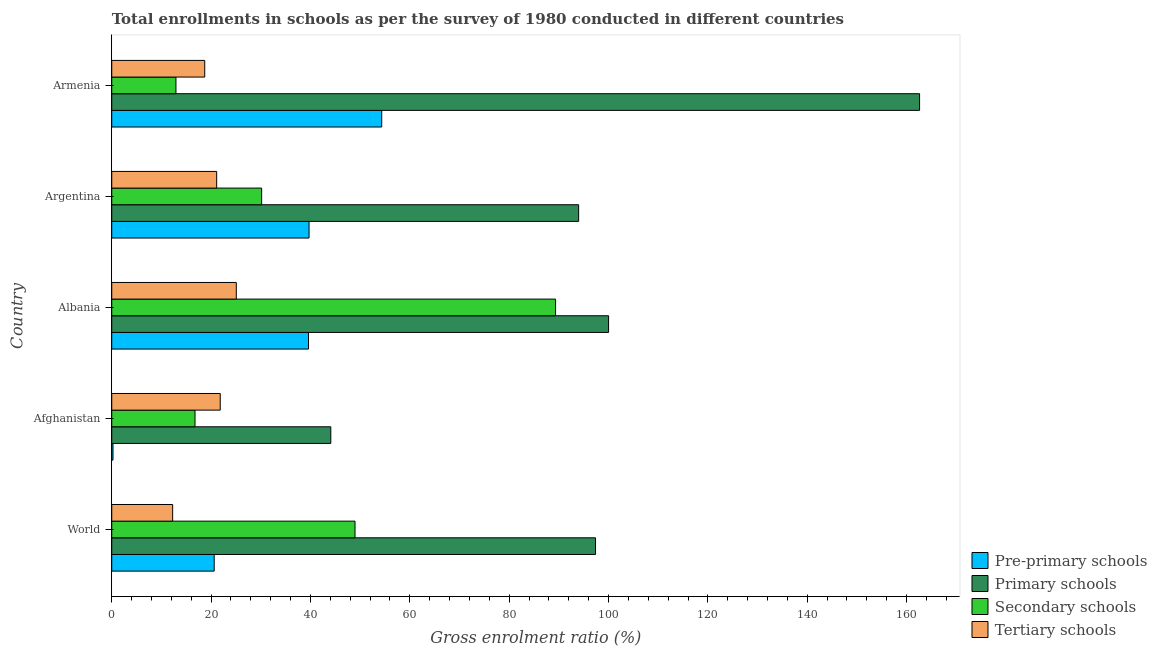How many different coloured bars are there?
Offer a terse response. 4. How many groups of bars are there?
Provide a succinct answer. 5. Are the number of bars per tick equal to the number of legend labels?
Make the answer very short. Yes. Are the number of bars on each tick of the Y-axis equal?
Give a very brief answer. Yes. What is the label of the 1st group of bars from the top?
Your response must be concise. Armenia. What is the gross enrolment ratio in pre-primary schools in World?
Ensure brevity in your answer.  20.62. Across all countries, what is the maximum gross enrolment ratio in tertiary schools?
Your response must be concise. 25.07. Across all countries, what is the minimum gross enrolment ratio in pre-primary schools?
Keep it short and to the point. 0.25. In which country was the gross enrolment ratio in secondary schools maximum?
Make the answer very short. Albania. In which country was the gross enrolment ratio in pre-primary schools minimum?
Offer a terse response. Afghanistan. What is the total gross enrolment ratio in secondary schools in the graph?
Keep it short and to the point. 198.17. What is the difference between the gross enrolment ratio in primary schools in Argentina and that in Armenia?
Your answer should be compact. -68.63. What is the difference between the gross enrolment ratio in primary schools in Argentina and the gross enrolment ratio in secondary schools in Albania?
Your answer should be very brief. 4.64. What is the average gross enrolment ratio in secondary schools per country?
Offer a terse response. 39.63. What is the difference between the gross enrolment ratio in pre-primary schools and gross enrolment ratio in primary schools in Argentina?
Keep it short and to the point. -54.27. In how many countries, is the gross enrolment ratio in pre-primary schools greater than 36 %?
Ensure brevity in your answer.  3. What is the ratio of the gross enrolment ratio in tertiary schools in Albania to that in Argentina?
Keep it short and to the point. 1.19. Is the gross enrolment ratio in pre-primary schools in Albania less than that in World?
Your response must be concise. No. What is the difference between the highest and the second highest gross enrolment ratio in secondary schools?
Provide a short and direct response. 40.37. What is the difference between the highest and the lowest gross enrolment ratio in secondary schools?
Your answer should be compact. 76.42. In how many countries, is the gross enrolment ratio in pre-primary schools greater than the average gross enrolment ratio in pre-primary schools taken over all countries?
Your answer should be very brief. 3. What does the 3rd bar from the top in Albania represents?
Give a very brief answer. Primary schools. What does the 4th bar from the bottom in Albania represents?
Provide a short and direct response. Tertiary schools. How many countries are there in the graph?
Offer a very short reply. 5. What is the difference between two consecutive major ticks on the X-axis?
Keep it short and to the point. 20. Does the graph contain any zero values?
Offer a terse response. No. Where does the legend appear in the graph?
Keep it short and to the point. Bottom right. How many legend labels are there?
Your answer should be compact. 4. How are the legend labels stacked?
Make the answer very short. Vertical. What is the title of the graph?
Provide a short and direct response. Total enrollments in schools as per the survey of 1980 conducted in different countries. What is the label or title of the Y-axis?
Give a very brief answer. Country. What is the Gross enrolment ratio (%) in Pre-primary schools in World?
Offer a very short reply. 20.62. What is the Gross enrolment ratio (%) in Primary schools in World?
Your answer should be very brief. 97.38. What is the Gross enrolment ratio (%) of Secondary schools in World?
Give a very brief answer. 48.97. What is the Gross enrolment ratio (%) of Tertiary schools in World?
Offer a terse response. 12.26. What is the Gross enrolment ratio (%) of Pre-primary schools in Afghanistan?
Make the answer very short. 0.25. What is the Gross enrolment ratio (%) of Primary schools in Afghanistan?
Ensure brevity in your answer.  44.1. What is the Gross enrolment ratio (%) in Secondary schools in Afghanistan?
Offer a very short reply. 16.76. What is the Gross enrolment ratio (%) in Tertiary schools in Afghanistan?
Offer a very short reply. 21.84. What is the Gross enrolment ratio (%) of Pre-primary schools in Albania?
Offer a terse response. 39.61. What is the Gross enrolment ratio (%) of Primary schools in Albania?
Ensure brevity in your answer.  100.01. What is the Gross enrolment ratio (%) of Secondary schools in Albania?
Your answer should be very brief. 89.34. What is the Gross enrolment ratio (%) in Tertiary schools in Albania?
Ensure brevity in your answer.  25.07. What is the Gross enrolment ratio (%) in Pre-primary schools in Argentina?
Ensure brevity in your answer.  39.72. What is the Gross enrolment ratio (%) in Primary schools in Argentina?
Make the answer very short. 93.98. What is the Gross enrolment ratio (%) of Secondary schools in Argentina?
Ensure brevity in your answer.  30.17. What is the Gross enrolment ratio (%) in Tertiary schools in Argentina?
Offer a very short reply. 21.12. What is the Gross enrolment ratio (%) of Pre-primary schools in Armenia?
Keep it short and to the point. 54.34. What is the Gross enrolment ratio (%) of Primary schools in Armenia?
Keep it short and to the point. 162.62. What is the Gross enrolment ratio (%) of Secondary schools in Armenia?
Keep it short and to the point. 12.93. What is the Gross enrolment ratio (%) of Tertiary schools in Armenia?
Offer a terse response. 18.72. Across all countries, what is the maximum Gross enrolment ratio (%) of Pre-primary schools?
Give a very brief answer. 54.34. Across all countries, what is the maximum Gross enrolment ratio (%) of Primary schools?
Provide a succinct answer. 162.62. Across all countries, what is the maximum Gross enrolment ratio (%) of Secondary schools?
Ensure brevity in your answer.  89.34. Across all countries, what is the maximum Gross enrolment ratio (%) in Tertiary schools?
Your response must be concise. 25.07. Across all countries, what is the minimum Gross enrolment ratio (%) of Pre-primary schools?
Provide a short and direct response. 0.25. Across all countries, what is the minimum Gross enrolment ratio (%) in Primary schools?
Ensure brevity in your answer.  44.1. Across all countries, what is the minimum Gross enrolment ratio (%) of Secondary schools?
Keep it short and to the point. 12.93. Across all countries, what is the minimum Gross enrolment ratio (%) of Tertiary schools?
Provide a short and direct response. 12.26. What is the total Gross enrolment ratio (%) in Pre-primary schools in the graph?
Offer a very short reply. 154.54. What is the total Gross enrolment ratio (%) in Primary schools in the graph?
Provide a short and direct response. 498.09. What is the total Gross enrolment ratio (%) in Secondary schools in the graph?
Ensure brevity in your answer.  198.17. What is the total Gross enrolment ratio (%) in Tertiary schools in the graph?
Offer a very short reply. 99.01. What is the difference between the Gross enrolment ratio (%) in Pre-primary schools in World and that in Afghanistan?
Provide a succinct answer. 20.37. What is the difference between the Gross enrolment ratio (%) in Primary schools in World and that in Afghanistan?
Keep it short and to the point. 53.29. What is the difference between the Gross enrolment ratio (%) of Secondary schools in World and that in Afghanistan?
Your answer should be compact. 32.21. What is the difference between the Gross enrolment ratio (%) in Tertiary schools in World and that in Afghanistan?
Your response must be concise. -9.58. What is the difference between the Gross enrolment ratio (%) of Pre-primary schools in World and that in Albania?
Offer a terse response. -18.98. What is the difference between the Gross enrolment ratio (%) in Primary schools in World and that in Albania?
Provide a short and direct response. -2.63. What is the difference between the Gross enrolment ratio (%) of Secondary schools in World and that in Albania?
Offer a very short reply. -40.37. What is the difference between the Gross enrolment ratio (%) of Tertiary schools in World and that in Albania?
Offer a very short reply. -12.81. What is the difference between the Gross enrolment ratio (%) of Pre-primary schools in World and that in Argentina?
Ensure brevity in your answer.  -19.1. What is the difference between the Gross enrolment ratio (%) in Primary schools in World and that in Argentina?
Provide a short and direct response. 3.4. What is the difference between the Gross enrolment ratio (%) of Secondary schools in World and that in Argentina?
Offer a terse response. 18.8. What is the difference between the Gross enrolment ratio (%) in Tertiary schools in World and that in Argentina?
Ensure brevity in your answer.  -8.86. What is the difference between the Gross enrolment ratio (%) in Pre-primary schools in World and that in Armenia?
Keep it short and to the point. -33.72. What is the difference between the Gross enrolment ratio (%) of Primary schools in World and that in Armenia?
Keep it short and to the point. -65.23. What is the difference between the Gross enrolment ratio (%) in Secondary schools in World and that in Armenia?
Offer a very short reply. 36.05. What is the difference between the Gross enrolment ratio (%) in Tertiary schools in World and that in Armenia?
Your answer should be very brief. -6.46. What is the difference between the Gross enrolment ratio (%) of Pre-primary schools in Afghanistan and that in Albania?
Your answer should be very brief. -39.35. What is the difference between the Gross enrolment ratio (%) in Primary schools in Afghanistan and that in Albania?
Keep it short and to the point. -55.92. What is the difference between the Gross enrolment ratio (%) in Secondary schools in Afghanistan and that in Albania?
Keep it short and to the point. -72.58. What is the difference between the Gross enrolment ratio (%) in Tertiary schools in Afghanistan and that in Albania?
Offer a terse response. -3.23. What is the difference between the Gross enrolment ratio (%) of Pre-primary schools in Afghanistan and that in Argentina?
Ensure brevity in your answer.  -39.46. What is the difference between the Gross enrolment ratio (%) of Primary schools in Afghanistan and that in Argentina?
Your answer should be very brief. -49.89. What is the difference between the Gross enrolment ratio (%) of Secondary schools in Afghanistan and that in Argentina?
Offer a terse response. -13.41. What is the difference between the Gross enrolment ratio (%) in Tertiary schools in Afghanistan and that in Argentina?
Make the answer very short. 0.72. What is the difference between the Gross enrolment ratio (%) in Pre-primary schools in Afghanistan and that in Armenia?
Give a very brief answer. -54.09. What is the difference between the Gross enrolment ratio (%) in Primary schools in Afghanistan and that in Armenia?
Give a very brief answer. -118.52. What is the difference between the Gross enrolment ratio (%) in Secondary schools in Afghanistan and that in Armenia?
Your answer should be compact. 3.84. What is the difference between the Gross enrolment ratio (%) of Tertiary schools in Afghanistan and that in Armenia?
Give a very brief answer. 3.12. What is the difference between the Gross enrolment ratio (%) of Pre-primary schools in Albania and that in Argentina?
Provide a succinct answer. -0.11. What is the difference between the Gross enrolment ratio (%) of Primary schools in Albania and that in Argentina?
Your answer should be compact. 6.03. What is the difference between the Gross enrolment ratio (%) in Secondary schools in Albania and that in Argentina?
Give a very brief answer. 59.17. What is the difference between the Gross enrolment ratio (%) of Tertiary schools in Albania and that in Argentina?
Your answer should be compact. 3.95. What is the difference between the Gross enrolment ratio (%) in Pre-primary schools in Albania and that in Armenia?
Your response must be concise. -14.74. What is the difference between the Gross enrolment ratio (%) of Primary schools in Albania and that in Armenia?
Give a very brief answer. -62.61. What is the difference between the Gross enrolment ratio (%) in Secondary schools in Albania and that in Armenia?
Keep it short and to the point. 76.42. What is the difference between the Gross enrolment ratio (%) of Tertiary schools in Albania and that in Armenia?
Provide a short and direct response. 6.35. What is the difference between the Gross enrolment ratio (%) in Pre-primary schools in Argentina and that in Armenia?
Your answer should be compact. -14.63. What is the difference between the Gross enrolment ratio (%) of Primary schools in Argentina and that in Armenia?
Keep it short and to the point. -68.63. What is the difference between the Gross enrolment ratio (%) in Secondary schools in Argentina and that in Armenia?
Keep it short and to the point. 17.25. What is the difference between the Gross enrolment ratio (%) in Tertiary schools in Argentina and that in Armenia?
Ensure brevity in your answer.  2.4. What is the difference between the Gross enrolment ratio (%) in Pre-primary schools in World and the Gross enrolment ratio (%) in Primary schools in Afghanistan?
Your response must be concise. -23.47. What is the difference between the Gross enrolment ratio (%) of Pre-primary schools in World and the Gross enrolment ratio (%) of Secondary schools in Afghanistan?
Offer a terse response. 3.86. What is the difference between the Gross enrolment ratio (%) of Pre-primary schools in World and the Gross enrolment ratio (%) of Tertiary schools in Afghanistan?
Offer a terse response. -1.22. What is the difference between the Gross enrolment ratio (%) of Primary schools in World and the Gross enrolment ratio (%) of Secondary schools in Afghanistan?
Your response must be concise. 80.62. What is the difference between the Gross enrolment ratio (%) of Primary schools in World and the Gross enrolment ratio (%) of Tertiary schools in Afghanistan?
Offer a terse response. 75.55. What is the difference between the Gross enrolment ratio (%) of Secondary schools in World and the Gross enrolment ratio (%) of Tertiary schools in Afghanistan?
Make the answer very short. 27.13. What is the difference between the Gross enrolment ratio (%) of Pre-primary schools in World and the Gross enrolment ratio (%) of Primary schools in Albania?
Offer a very short reply. -79.39. What is the difference between the Gross enrolment ratio (%) in Pre-primary schools in World and the Gross enrolment ratio (%) in Secondary schools in Albania?
Give a very brief answer. -68.72. What is the difference between the Gross enrolment ratio (%) in Pre-primary schools in World and the Gross enrolment ratio (%) in Tertiary schools in Albania?
Your answer should be compact. -4.45. What is the difference between the Gross enrolment ratio (%) of Primary schools in World and the Gross enrolment ratio (%) of Secondary schools in Albania?
Provide a short and direct response. 8.04. What is the difference between the Gross enrolment ratio (%) of Primary schools in World and the Gross enrolment ratio (%) of Tertiary schools in Albania?
Your answer should be very brief. 72.31. What is the difference between the Gross enrolment ratio (%) in Secondary schools in World and the Gross enrolment ratio (%) in Tertiary schools in Albania?
Offer a very short reply. 23.9. What is the difference between the Gross enrolment ratio (%) of Pre-primary schools in World and the Gross enrolment ratio (%) of Primary schools in Argentina?
Offer a very short reply. -73.36. What is the difference between the Gross enrolment ratio (%) in Pre-primary schools in World and the Gross enrolment ratio (%) in Secondary schools in Argentina?
Ensure brevity in your answer.  -9.55. What is the difference between the Gross enrolment ratio (%) of Pre-primary schools in World and the Gross enrolment ratio (%) of Tertiary schools in Argentina?
Provide a succinct answer. -0.5. What is the difference between the Gross enrolment ratio (%) in Primary schools in World and the Gross enrolment ratio (%) in Secondary schools in Argentina?
Your answer should be very brief. 67.21. What is the difference between the Gross enrolment ratio (%) of Primary schools in World and the Gross enrolment ratio (%) of Tertiary schools in Argentina?
Ensure brevity in your answer.  76.26. What is the difference between the Gross enrolment ratio (%) in Secondary schools in World and the Gross enrolment ratio (%) in Tertiary schools in Argentina?
Your response must be concise. 27.85. What is the difference between the Gross enrolment ratio (%) of Pre-primary schools in World and the Gross enrolment ratio (%) of Primary schools in Armenia?
Your response must be concise. -142. What is the difference between the Gross enrolment ratio (%) in Pre-primary schools in World and the Gross enrolment ratio (%) in Secondary schools in Armenia?
Provide a succinct answer. 7.7. What is the difference between the Gross enrolment ratio (%) of Pre-primary schools in World and the Gross enrolment ratio (%) of Tertiary schools in Armenia?
Your answer should be compact. 1.9. What is the difference between the Gross enrolment ratio (%) of Primary schools in World and the Gross enrolment ratio (%) of Secondary schools in Armenia?
Your answer should be compact. 84.46. What is the difference between the Gross enrolment ratio (%) of Primary schools in World and the Gross enrolment ratio (%) of Tertiary schools in Armenia?
Your response must be concise. 78.66. What is the difference between the Gross enrolment ratio (%) of Secondary schools in World and the Gross enrolment ratio (%) of Tertiary schools in Armenia?
Your answer should be compact. 30.25. What is the difference between the Gross enrolment ratio (%) in Pre-primary schools in Afghanistan and the Gross enrolment ratio (%) in Primary schools in Albania?
Provide a short and direct response. -99.76. What is the difference between the Gross enrolment ratio (%) of Pre-primary schools in Afghanistan and the Gross enrolment ratio (%) of Secondary schools in Albania?
Your answer should be very brief. -89.09. What is the difference between the Gross enrolment ratio (%) in Pre-primary schools in Afghanistan and the Gross enrolment ratio (%) in Tertiary schools in Albania?
Keep it short and to the point. -24.82. What is the difference between the Gross enrolment ratio (%) in Primary schools in Afghanistan and the Gross enrolment ratio (%) in Secondary schools in Albania?
Offer a terse response. -45.25. What is the difference between the Gross enrolment ratio (%) in Primary schools in Afghanistan and the Gross enrolment ratio (%) in Tertiary schools in Albania?
Give a very brief answer. 19.02. What is the difference between the Gross enrolment ratio (%) in Secondary schools in Afghanistan and the Gross enrolment ratio (%) in Tertiary schools in Albania?
Offer a very short reply. -8.31. What is the difference between the Gross enrolment ratio (%) of Pre-primary schools in Afghanistan and the Gross enrolment ratio (%) of Primary schools in Argentina?
Provide a succinct answer. -93.73. What is the difference between the Gross enrolment ratio (%) in Pre-primary schools in Afghanistan and the Gross enrolment ratio (%) in Secondary schools in Argentina?
Provide a short and direct response. -29.92. What is the difference between the Gross enrolment ratio (%) in Pre-primary schools in Afghanistan and the Gross enrolment ratio (%) in Tertiary schools in Argentina?
Provide a short and direct response. -20.87. What is the difference between the Gross enrolment ratio (%) of Primary schools in Afghanistan and the Gross enrolment ratio (%) of Secondary schools in Argentina?
Give a very brief answer. 13.92. What is the difference between the Gross enrolment ratio (%) of Primary schools in Afghanistan and the Gross enrolment ratio (%) of Tertiary schools in Argentina?
Your answer should be very brief. 22.97. What is the difference between the Gross enrolment ratio (%) in Secondary schools in Afghanistan and the Gross enrolment ratio (%) in Tertiary schools in Argentina?
Provide a succinct answer. -4.36. What is the difference between the Gross enrolment ratio (%) in Pre-primary schools in Afghanistan and the Gross enrolment ratio (%) in Primary schools in Armenia?
Provide a succinct answer. -162.36. What is the difference between the Gross enrolment ratio (%) of Pre-primary schools in Afghanistan and the Gross enrolment ratio (%) of Secondary schools in Armenia?
Your answer should be very brief. -12.67. What is the difference between the Gross enrolment ratio (%) in Pre-primary schools in Afghanistan and the Gross enrolment ratio (%) in Tertiary schools in Armenia?
Provide a succinct answer. -18.47. What is the difference between the Gross enrolment ratio (%) of Primary schools in Afghanistan and the Gross enrolment ratio (%) of Secondary schools in Armenia?
Make the answer very short. 31.17. What is the difference between the Gross enrolment ratio (%) of Primary schools in Afghanistan and the Gross enrolment ratio (%) of Tertiary schools in Armenia?
Provide a succinct answer. 25.38. What is the difference between the Gross enrolment ratio (%) in Secondary schools in Afghanistan and the Gross enrolment ratio (%) in Tertiary schools in Armenia?
Your response must be concise. -1.96. What is the difference between the Gross enrolment ratio (%) in Pre-primary schools in Albania and the Gross enrolment ratio (%) in Primary schools in Argentina?
Your answer should be compact. -54.38. What is the difference between the Gross enrolment ratio (%) in Pre-primary schools in Albania and the Gross enrolment ratio (%) in Secondary schools in Argentina?
Your answer should be compact. 9.43. What is the difference between the Gross enrolment ratio (%) of Pre-primary schools in Albania and the Gross enrolment ratio (%) of Tertiary schools in Argentina?
Offer a very short reply. 18.48. What is the difference between the Gross enrolment ratio (%) in Primary schools in Albania and the Gross enrolment ratio (%) in Secondary schools in Argentina?
Provide a succinct answer. 69.84. What is the difference between the Gross enrolment ratio (%) of Primary schools in Albania and the Gross enrolment ratio (%) of Tertiary schools in Argentina?
Your answer should be very brief. 78.89. What is the difference between the Gross enrolment ratio (%) in Secondary schools in Albania and the Gross enrolment ratio (%) in Tertiary schools in Argentina?
Offer a terse response. 68.22. What is the difference between the Gross enrolment ratio (%) in Pre-primary schools in Albania and the Gross enrolment ratio (%) in Primary schools in Armenia?
Make the answer very short. -123.01. What is the difference between the Gross enrolment ratio (%) of Pre-primary schools in Albania and the Gross enrolment ratio (%) of Secondary schools in Armenia?
Your answer should be very brief. 26.68. What is the difference between the Gross enrolment ratio (%) in Pre-primary schools in Albania and the Gross enrolment ratio (%) in Tertiary schools in Armenia?
Offer a terse response. 20.89. What is the difference between the Gross enrolment ratio (%) of Primary schools in Albania and the Gross enrolment ratio (%) of Secondary schools in Armenia?
Give a very brief answer. 87.09. What is the difference between the Gross enrolment ratio (%) in Primary schools in Albania and the Gross enrolment ratio (%) in Tertiary schools in Armenia?
Provide a short and direct response. 81.29. What is the difference between the Gross enrolment ratio (%) in Secondary schools in Albania and the Gross enrolment ratio (%) in Tertiary schools in Armenia?
Provide a succinct answer. 70.62. What is the difference between the Gross enrolment ratio (%) of Pre-primary schools in Argentina and the Gross enrolment ratio (%) of Primary schools in Armenia?
Provide a succinct answer. -122.9. What is the difference between the Gross enrolment ratio (%) in Pre-primary schools in Argentina and the Gross enrolment ratio (%) in Secondary schools in Armenia?
Make the answer very short. 26.79. What is the difference between the Gross enrolment ratio (%) in Pre-primary schools in Argentina and the Gross enrolment ratio (%) in Tertiary schools in Armenia?
Ensure brevity in your answer.  21. What is the difference between the Gross enrolment ratio (%) in Primary schools in Argentina and the Gross enrolment ratio (%) in Secondary schools in Armenia?
Your answer should be compact. 81.06. What is the difference between the Gross enrolment ratio (%) of Primary schools in Argentina and the Gross enrolment ratio (%) of Tertiary schools in Armenia?
Your answer should be very brief. 75.27. What is the difference between the Gross enrolment ratio (%) of Secondary schools in Argentina and the Gross enrolment ratio (%) of Tertiary schools in Armenia?
Your answer should be compact. 11.45. What is the average Gross enrolment ratio (%) in Pre-primary schools per country?
Provide a short and direct response. 30.91. What is the average Gross enrolment ratio (%) of Primary schools per country?
Make the answer very short. 99.62. What is the average Gross enrolment ratio (%) in Secondary schools per country?
Ensure brevity in your answer.  39.63. What is the average Gross enrolment ratio (%) of Tertiary schools per country?
Make the answer very short. 19.8. What is the difference between the Gross enrolment ratio (%) in Pre-primary schools and Gross enrolment ratio (%) in Primary schools in World?
Keep it short and to the point. -76.76. What is the difference between the Gross enrolment ratio (%) in Pre-primary schools and Gross enrolment ratio (%) in Secondary schools in World?
Offer a very short reply. -28.35. What is the difference between the Gross enrolment ratio (%) of Pre-primary schools and Gross enrolment ratio (%) of Tertiary schools in World?
Offer a terse response. 8.36. What is the difference between the Gross enrolment ratio (%) in Primary schools and Gross enrolment ratio (%) in Secondary schools in World?
Offer a very short reply. 48.41. What is the difference between the Gross enrolment ratio (%) of Primary schools and Gross enrolment ratio (%) of Tertiary schools in World?
Provide a short and direct response. 85.12. What is the difference between the Gross enrolment ratio (%) of Secondary schools and Gross enrolment ratio (%) of Tertiary schools in World?
Make the answer very short. 36.71. What is the difference between the Gross enrolment ratio (%) in Pre-primary schools and Gross enrolment ratio (%) in Primary schools in Afghanistan?
Ensure brevity in your answer.  -43.84. What is the difference between the Gross enrolment ratio (%) in Pre-primary schools and Gross enrolment ratio (%) in Secondary schools in Afghanistan?
Your answer should be very brief. -16.51. What is the difference between the Gross enrolment ratio (%) of Pre-primary schools and Gross enrolment ratio (%) of Tertiary schools in Afghanistan?
Your response must be concise. -21.59. What is the difference between the Gross enrolment ratio (%) of Primary schools and Gross enrolment ratio (%) of Secondary schools in Afghanistan?
Your answer should be compact. 27.33. What is the difference between the Gross enrolment ratio (%) of Primary schools and Gross enrolment ratio (%) of Tertiary schools in Afghanistan?
Offer a terse response. 22.26. What is the difference between the Gross enrolment ratio (%) in Secondary schools and Gross enrolment ratio (%) in Tertiary schools in Afghanistan?
Provide a succinct answer. -5.07. What is the difference between the Gross enrolment ratio (%) in Pre-primary schools and Gross enrolment ratio (%) in Primary schools in Albania?
Your answer should be compact. -60.4. What is the difference between the Gross enrolment ratio (%) of Pre-primary schools and Gross enrolment ratio (%) of Secondary schools in Albania?
Your answer should be very brief. -49.74. What is the difference between the Gross enrolment ratio (%) in Pre-primary schools and Gross enrolment ratio (%) in Tertiary schools in Albania?
Provide a short and direct response. 14.54. What is the difference between the Gross enrolment ratio (%) of Primary schools and Gross enrolment ratio (%) of Secondary schools in Albania?
Provide a short and direct response. 10.67. What is the difference between the Gross enrolment ratio (%) of Primary schools and Gross enrolment ratio (%) of Tertiary schools in Albania?
Provide a succinct answer. 74.94. What is the difference between the Gross enrolment ratio (%) in Secondary schools and Gross enrolment ratio (%) in Tertiary schools in Albania?
Provide a short and direct response. 64.27. What is the difference between the Gross enrolment ratio (%) in Pre-primary schools and Gross enrolment ratio (%) in Primary schools in Argentina?
Offer a very short reply. -54.27. What is the difference between the Gross enrolment ratio (%) of Pre-primary schools and Gross enrolment ratio (%) of Secondary schools in Argentina?
Ensure brevity in your answer.  9.54. What is the difference between the Gross enrolment ratio (%) in Pre-primary schools and Gross enrolment ratio (%) in Tertiary schools in Argentina?
Make the answer very short. 18.6. What is the difference between the Gross enrolment ratio (%) of Primary schools and Gross enrolment ratio (%) of Secondary schools in Argentina?
Provide a succinct answer. 63.81. What is the difference between the Gross enrolment ratio (%) in Primary schools and Gross enrolment ratio (%) in Tertiary schools in Argentina?
Give a very brief answer. 72.86. What is the difference between the Gross enrolment ratio (%) of Secondary schools and Gross enrolment ratio (%) of Tertiary schools in Argentina?
Your response must be concise. 9.05. What is the difference between the Gross enrolment ratio (%) in Pre-primary schools and Gross enrolment ratio (%) in Primary schools in Armenia?
Make the answer very short. -108.27. What is the difference between the Gross enrolment ratio (%) of Pre-primary schools and Gross enrolment ratio (%) of Secondary schools in Armenia?
Your answer should be compact. 41.42. What is the difference between the Gross enrolment ratio (%) of Pre-primary schools and Gross enrolment ratio (%) of Tertiary schools in Armenia?
Offer a very short reply. 35.63. What is the difference between the Gross enrolment ratio (%) in Primary schools and Gross enrolment ratio (%) in Secondary schools in Armenia?
Keep it short and to the point. 149.69. What is the difference between the Gross enrolment ratio (%) in Primary schools and Gross enrolment ratio (%) in Tertiary schools in Armenia?
Provide a short and direct response. 143.9. What is the difference between the Gross enrolment ratio (%) in Secondary schools and Gross enrolment ratio (%) in Tertiary schools in Armenia?
Give a very brief answer. -5.79. What is the ratio of the Gross enrolment ratio (%) of Pre-primary schools in World to that in Afghanistan?
Make the answer very short. 81.79. What is the ratio of the Gross enrolment ratio (%) of Primary schools in World to that in Afghanistan?
Offer a terse response. 2.21. What is the ratio of the Gross enrolment ratio (%) in Secondary schools in World to that in Afghanistan?
Provide a short and direct response. 2.92. What is the ratio of the Gross enrolment ratio (%) in Tertiary schools in World to that in Afghanistan?
Offer a terse response. 0.56. What is the ratio of the Gross enrolment ratio (%) of Pre-primary schools in World to that in Albania?
Your response must be concise. 0.52. What is the ratio of the Gross enrolment ratio (%) in Primary schools in World to that in Albania?
Make the answer very short. 0.97. What is the ratio of the Gross enrolment ratio (%) in Secondary schools in World to that in Albania?
Your answer should be very brief. 0.55. What is the ratio of the Gross enrolment ratio (%) of Tertiary schools in World to that in Albania?
Your answer should be compact. 0.49. What is the ratio of the Gross enrolment ratio (%) of Pre-primary schools in World to that in Argentina?
Ensure brevity in your answer.  0.52. What is the ratio of the Gross enrolment ratio (%) of Primary schools in World to that in Argentina?
Give a very brief answer. 1.04. What is the ratio of the Gross enrolment ratio (%) of Secondary schools in World to that in Argentina?
Offer a very short reply. 1.62. What is the ratio of the Gross enrolment ratio (%) in Tertiary schools in World to that in Argentina?
Keep it short and to the point. 0.58. What is the ratio of the Gross enrolment ratio (%) in Pre-primary schools in World to that in Armenia?
Your answer should be compact. 0.38. What is the ratio of the Gross enrolment ratio (%) in Primary schools in World to that in Armenia?
Ensure brevity in your answer.  0.6. What is the ratio of the Gross enrolment ratio (%) of Secondary schools in World to that in Armenia?
Make the answer very short. 3.79. What is the ratio of the Gross enrolment ratio (%) of Tertiary schools in World to that in Armenia?
Your answer should be compact. 0.66. What is the ratio of the Gross enrolment ratio (%) of Pre-primary schools in Afghanistan to that in Albania?
Ensure brevity in your answer.  0.01. What is the ratio of the Gross enrolment ratio (%) in Primary schools in Afghanistan to that in Albania?
Offer a very short reply. 0.44. What is the ratio of the Gross enrolment ratio (%) in Secondary schools in Afghanistan to that in Albania?
Your answer should be compact. 0.19. What is the ratio of the Gross enrolment ratio (%) in Tertiary schools in Afghanistan to that in Albania?
Offer a very short reply. 0.87. What is the ratio of the Gross enrolment ratio (%) in Pre-primary schools in Afghanistan to that in Argentina?
Keep it short and to the point. 0.01. What is the ratio of the Gross enrolment ratio (%) of Primary schools in Afghanistan to that in Argentina?
Your answer should be compact. 0.47. What is the ratio of the Gross enrolment ratio (%) in Secondary schools in Afghanistan to that in Argentina?
Your response must be concise. 0.56. What is the ratio of the Gross enrolment ratio (%) in Tertiary schools in Afghanistan to that in Argentina?
Make the answer very short. 1.03. What is the ratio of the Gross enrolment ratio (%) of Pre-primary schools in Afghanistan to that in Armenia?
Keep it short and to the point. 0. What is the ratio of the Gross enrolment ratio (%) of Primary schools in Afghanistan to that in Armenia?
Provide a short and direct response. 0.27. What is the ratio of the Gross enrolment ratio (%) of Secondary schools in Afghanistan to that in Armenia?
Offer a terse response. 1.3. What is the ratio of the Gross enrolment ratio (%) in Tertiary schools in Afghanistan to that in Armenia?
Make the answer very short. 1.17. What is the ratio of the Gross enrolment ratio (%) of Primary schools in Albania to that in Argentina?
Provide a short and direct response. 1.06. What is the ratio of the Gross enrolment ratio (%) of Secondary schools in Albania to that in Argentina?
Your answer should be compact. 2.96. What is the ratio of the Gross enrolment ratio (%) in Tertiary schools in Albania to that in Argentina?
Ensure brevity in your answer.  1.19. What is the ratio of the Gross enrolment ratio (%) in Pre-primary schools in Albania to that in Armenia?
Your answer should be compact. 0.73. What is the ratio of the Gross enrolment ratio (%) in Primary schools in Albania to that in Armenia?
Keep it short and to the point. 0.61. What is the ratio of the Gross enrolment ratio (%) of Secondary schools in Albania to that in Armenia?
Offer a terse response. 6.91. What is the ratio of the Gross enrolment ratio (%) of Tertiary schools in Albania to that in Armenia?
Offer a very short reply. 1.34. What is the ratio of the Gross enrolment ratio (%) in Pre-primary schools in Argentina to that in Armenia?
Ensure brevity in your answer.  0.73. What is the ratio of the Gross enrolment ratio (%) in Primary schools in Argentina to that in Armenia?
Provide a succinct answer. 0.58. What is the ratio of the Gross enrolment ratio (%) of Secondary schools in Argentina to that in Armenia?
Keep it short and to the point. 2.33. What is the ratio of the Gross enrolment ratio (%) of Tertiary schools in Argentina to that in Armenia?
Provide a short and direct response. 1.13. What is the difference between the highest and the second highest Gross enrolment ratio (%) in Pre-primary schools?
Provide a succinct answer. 14.63. What is the difference between the highest and the second highest Gross enrolment ratio (%) in Primary schools?
Give a very brief answer. 62.61. What is the difference between the highest and the second highest Gross enrolment ratio (%) in Secondary schools?
Give a very brief answer. 40.37. What is the difference between the highest and the second highest Gross enrolment ratio (%) in Tertiary schools?
Ensure brevity in your answer.  3.23. What is the difference between the highest and the lowest Gross enrolment ratio (%) of Pre-primary schools?
Make the answer very short. 54.09. What is the difference between the highest and the lowest Gross enrolment ratio (%) in Primary schools?
Give a very brief answer. 118.52. What is the difference between the highest and the lowest Gross enrolment ratio (%) of Secondary schools?
Your answer should be very brief. 76.42. What is the difference between the highest and the lowest Gross enrolment ratio (%) of Tertiary schools?
Ensure brevity in your answer.  12.81. 